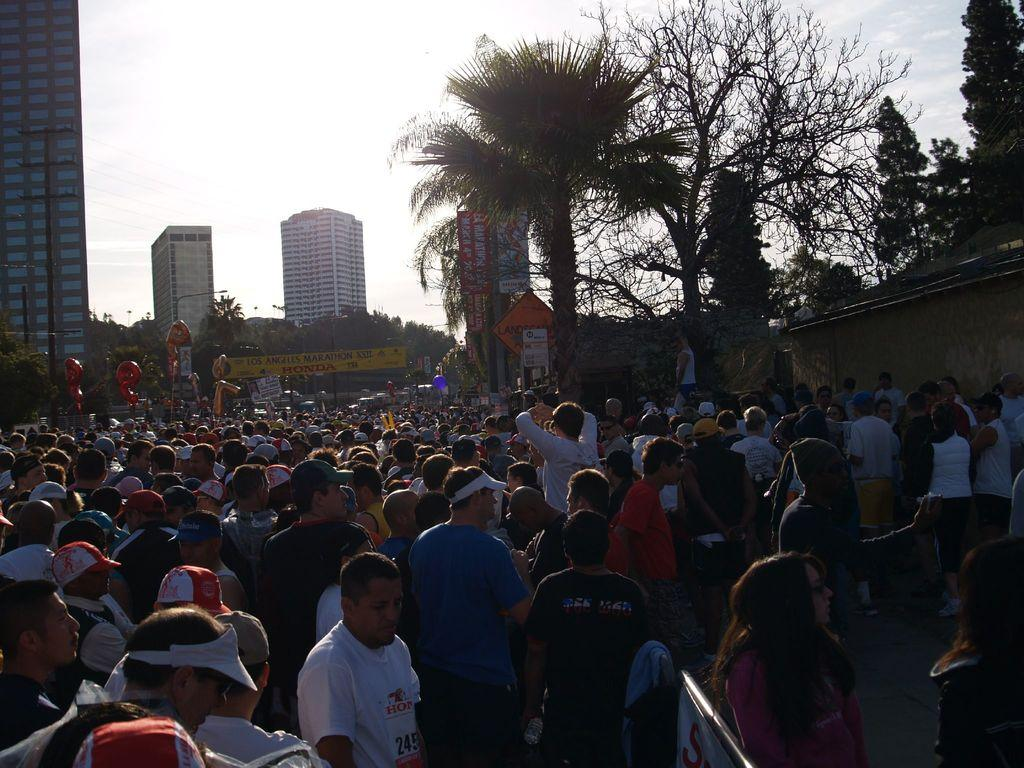What is located in the foreground of the image? There is a crowd in the foreground of the image. What can be seen in the middle of the image? There are trees, buildings, and various objects present in the middle of the image. Can you describe the sky in the image? The sky is visible at the top of the image. Can you see any deer in the image? There are no deer present in the image. What type of exchange is happening between the people in the image? There is no exchange happening between the people in the image; it only shows a crowd. Is there a quill visible in the image? There is no quill present in the image. 